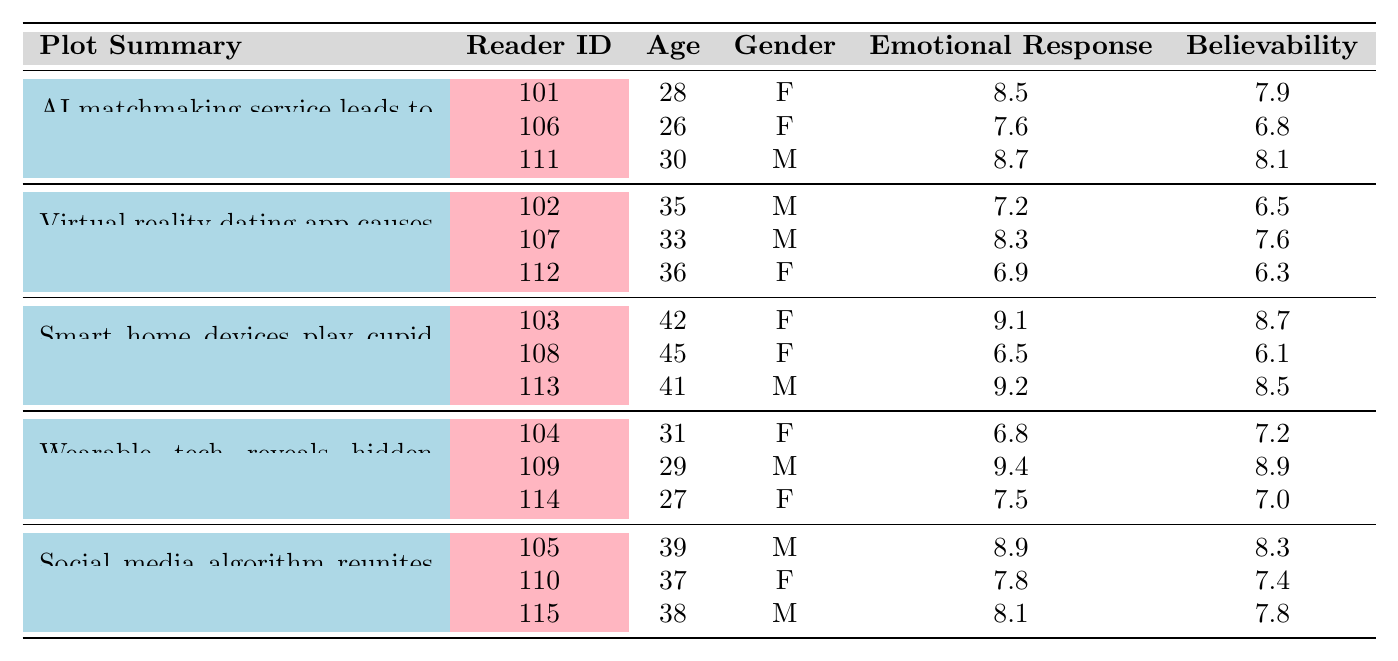What is the emotional response score for plot summary about the AI matchmaking service? There are three instances of the plot about the AI matchmaking service. The emotional response scores are 8.5, 7.6, and 8.7.
Answer: 8.5, 7.6, 8.7 Which plot had the highest believability score? By examining the believability scores across all plot summaries, the maximum score is 9.6 for the plot about wearable tech revealing hidden emotions in office romance.
Answer: 9.6 What is the average emotional response score for the plot involving smart home devices? The emotional response scores for the smart home devices plot are 9.1, 6.5, and 9.2. Their sum is 24.8, and the average is 24.8 divided by 3, which equals approximately 8.27.
Answer: Approximately 8.27 Which reader had the highest emotional response score overall? Scanning through the emotional response scores, the highest score is 9.4, given by reader ID 109.
Answer: 109 Did any male reader give the lowest emotional response score? Out of the readers, the lowest emotional response score is 6.5, which was given by reader ID 108, who is female. So, no male reader gave the lowest score.
Answer: No What is the average believability score for plots with social media algorithms? The believability scores for social media algorithm plot are 8.3, 7.4, and 7.8. The total is 23.5, and the average is 23.5 divided by 3, equaling approximately 7.83.
Answer: Approximately 7.83 Which plot had the lowest emotional response among female readers? The emotional response scores for female readers are 8.5, 7.6, 9.1, 6.8, 7.8, 7.5, and 6.5. The lowest score in this set is 6.5, related to the smart home devices plot.
Answer: Smart home devices plot How many readers would recommend the AI matchmaking service plot? The readers' recommendations for the AI matchmaking service plot (IDs 101, 106, and 111) show that 2 out of 3 readers recommended it, since IDs 101 and 111 said yes.
Answer: 2 Do most readers find the virtual reality dating app plot believable? The believability scores for the virtual reality dating app plot are 6.5, 7.6, and 6.3. Since the highest score is lower than 8, it indicates that most readers likely do not find it believable.
Answer: No What is the sum of the emotional response scores for all female readers? The emotional response scores for female readers are 8.5, 9.1, 6.8, 7.8, 7.5, and 6.5, totaling 46.9.
Answer: 46.9 